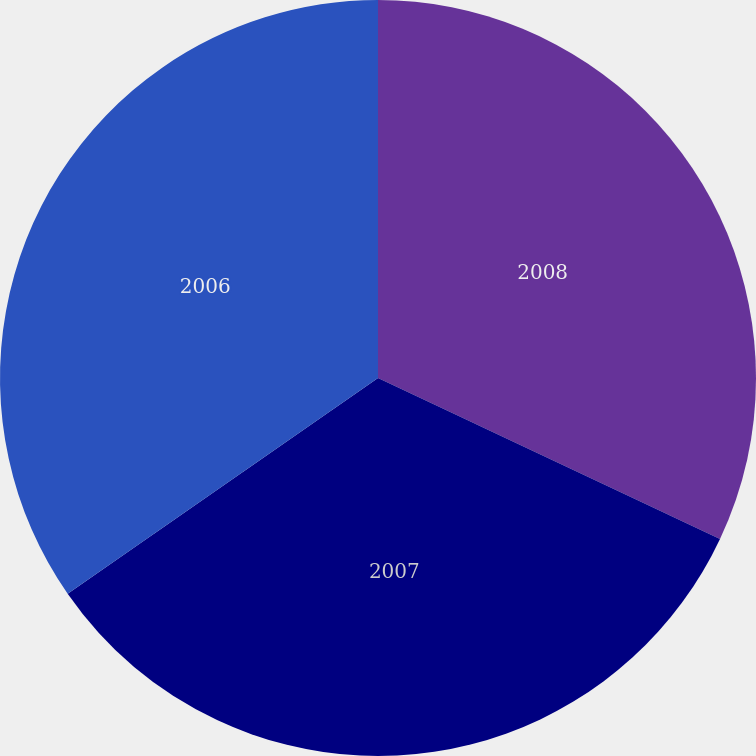Convert chart to OTSL. <chart><loc_0><loc_0><loc_500><loc_500><pie_chart><fcel>2008<fcel>2007<fcel>2006<nl><fcel>32.0%<fcel>33.33%<fcel>34.67%<nl></chart> 